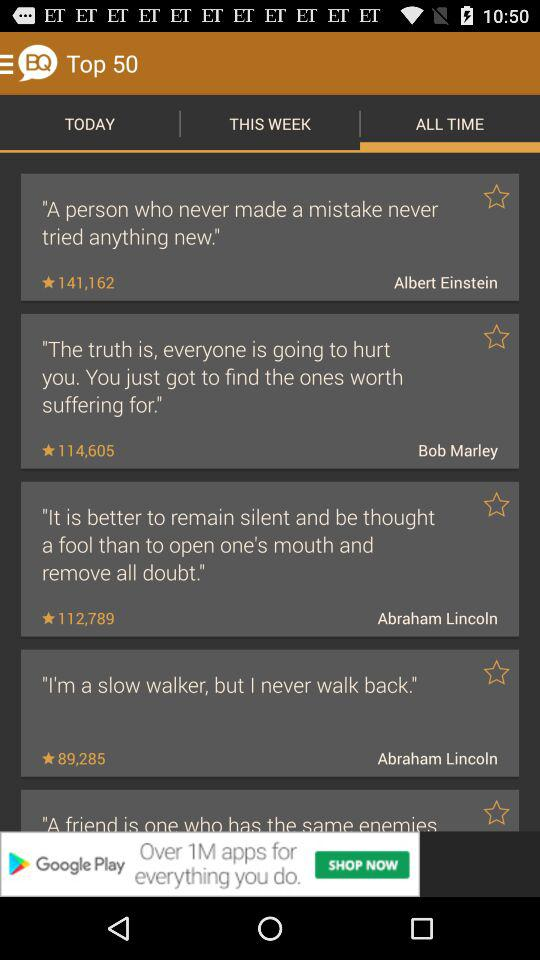What has been written by Bob Marley? Bob Marley has written, "The truth is, everyone is going to hurt you. You just got to find the ones worth suffering for". 